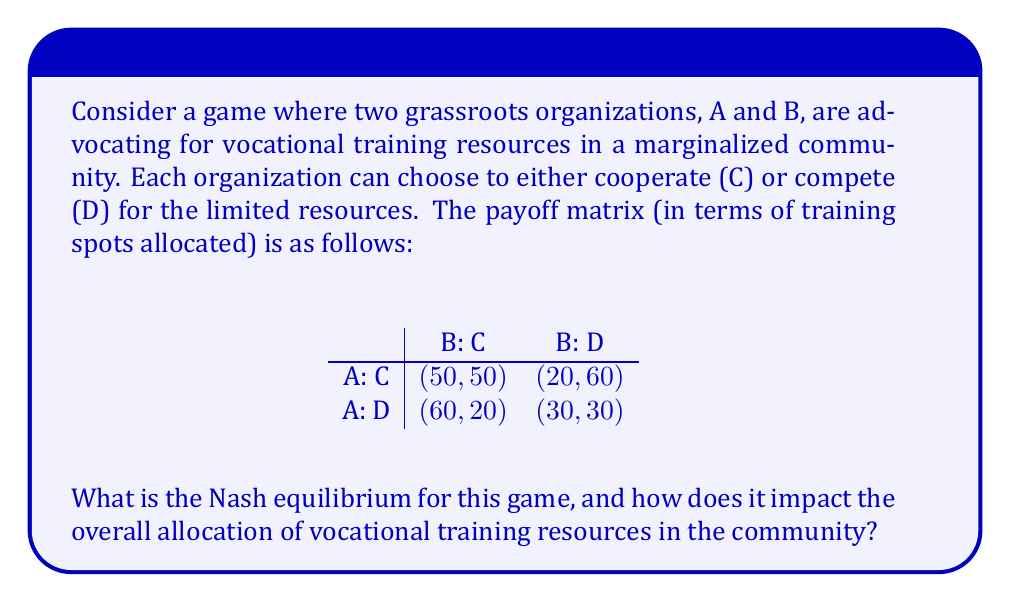What is the answer to this math problem? To find the Nash equilibrium, we need to analyze each player's best response to the other player's strategy:

1. For Organization A:
   - If B chooses C, A's best response is D (60 > 50)
   - If B chooses D, A's best response is D (30 > 20)

2. For Organization B:
   - If A chooses C, B's best response is D (60 > 50)
   - If A chooses D, B's best response is D (30 > 20)

The Nash equilibrium occurs when both players are playing their best responses to each other's strategies. In this case, the Nash equilibrium is (D, D), where both organizations choose to compete.

To verify this, let's check if any player has an incentive to unilaterally deviate:
- If A switches to C while B stays at D, A's payoff decreases from 30 to 20
- If B switches to C while A stays at D, B's payoff decreases from 30 to 20

Neither player has an incentive to change their strategy, confirming that (D, D) is indeed the Nash equilibrium.

Impact on resource allocation:
At the Nash equilibrium (D, D), each organization receives 30 training spots, for a total of 60 spots allocated in the community. This is less than the 100 total spots that could be allocated if both organizations cooperated (C, C). The competitive nature of the Nash equilibrium leads to a suboptimal outcome for the community as a whole, demonstrating the "prisoner's dilemma" aspect of this game.

This result highlights the challenges faced by grassroots activists in advocating for equal access to vocational training. While competition may seem like the dominant strategy for individual organizations, it ultimately results in fewer resources for the marginalized community they aim to serve.
Answer: The Nash equilibrium for this game is (D, D), where both organizations choose to compete. This results in each organization receiving 30 training spots, for a total of 60 spots allocated in the community. This outcome is suboptimal compared to the cooperative strategy (C, C), which would result in a total of 100 training spots allocated. 